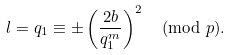Convert formula to latex. <formula><loc_0><loc_0><loc_500><loc_500>l = q _ { 1 } \equiv \pm \left ( \frac { 2 b } { q _ { 1 } ^ { m } } \right ) ^ { 2 } \pmod { p } .</formula> 